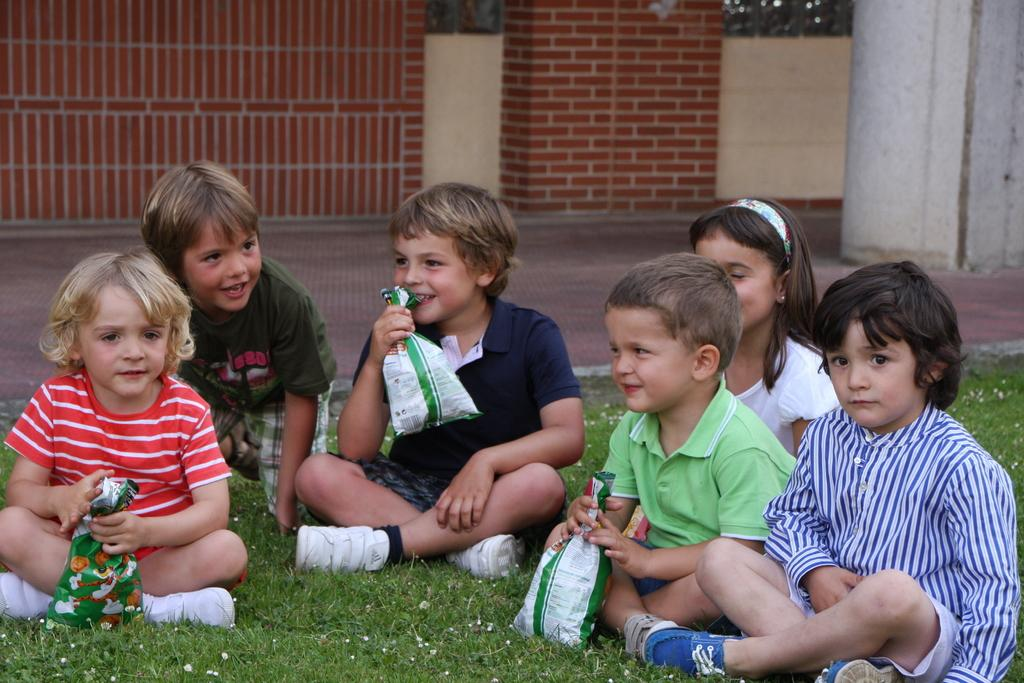What is the location of the kids in the image? The kids are on the grassland in the image. What are some of the kids holding? Some kids are holding packets in the image. Can you describe any structures or objects on the right side of the image? There is a pillar on the floor on the right side of the image. What can be seen in the background of the image? There is a wall with a window in the background of the image. Can you see a kitten playing with a spoon near the kids in the image? No, there is no kitten or spoon present in the image. How many jellyfish are swimming in the grassland with the kids? There are no jellyfish in the image, as it is a grassland and not an aquatic environment. 